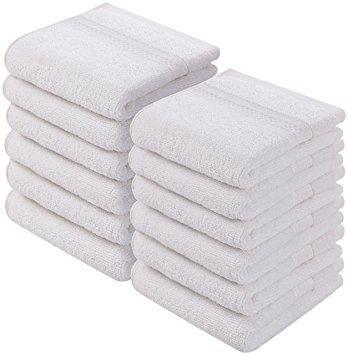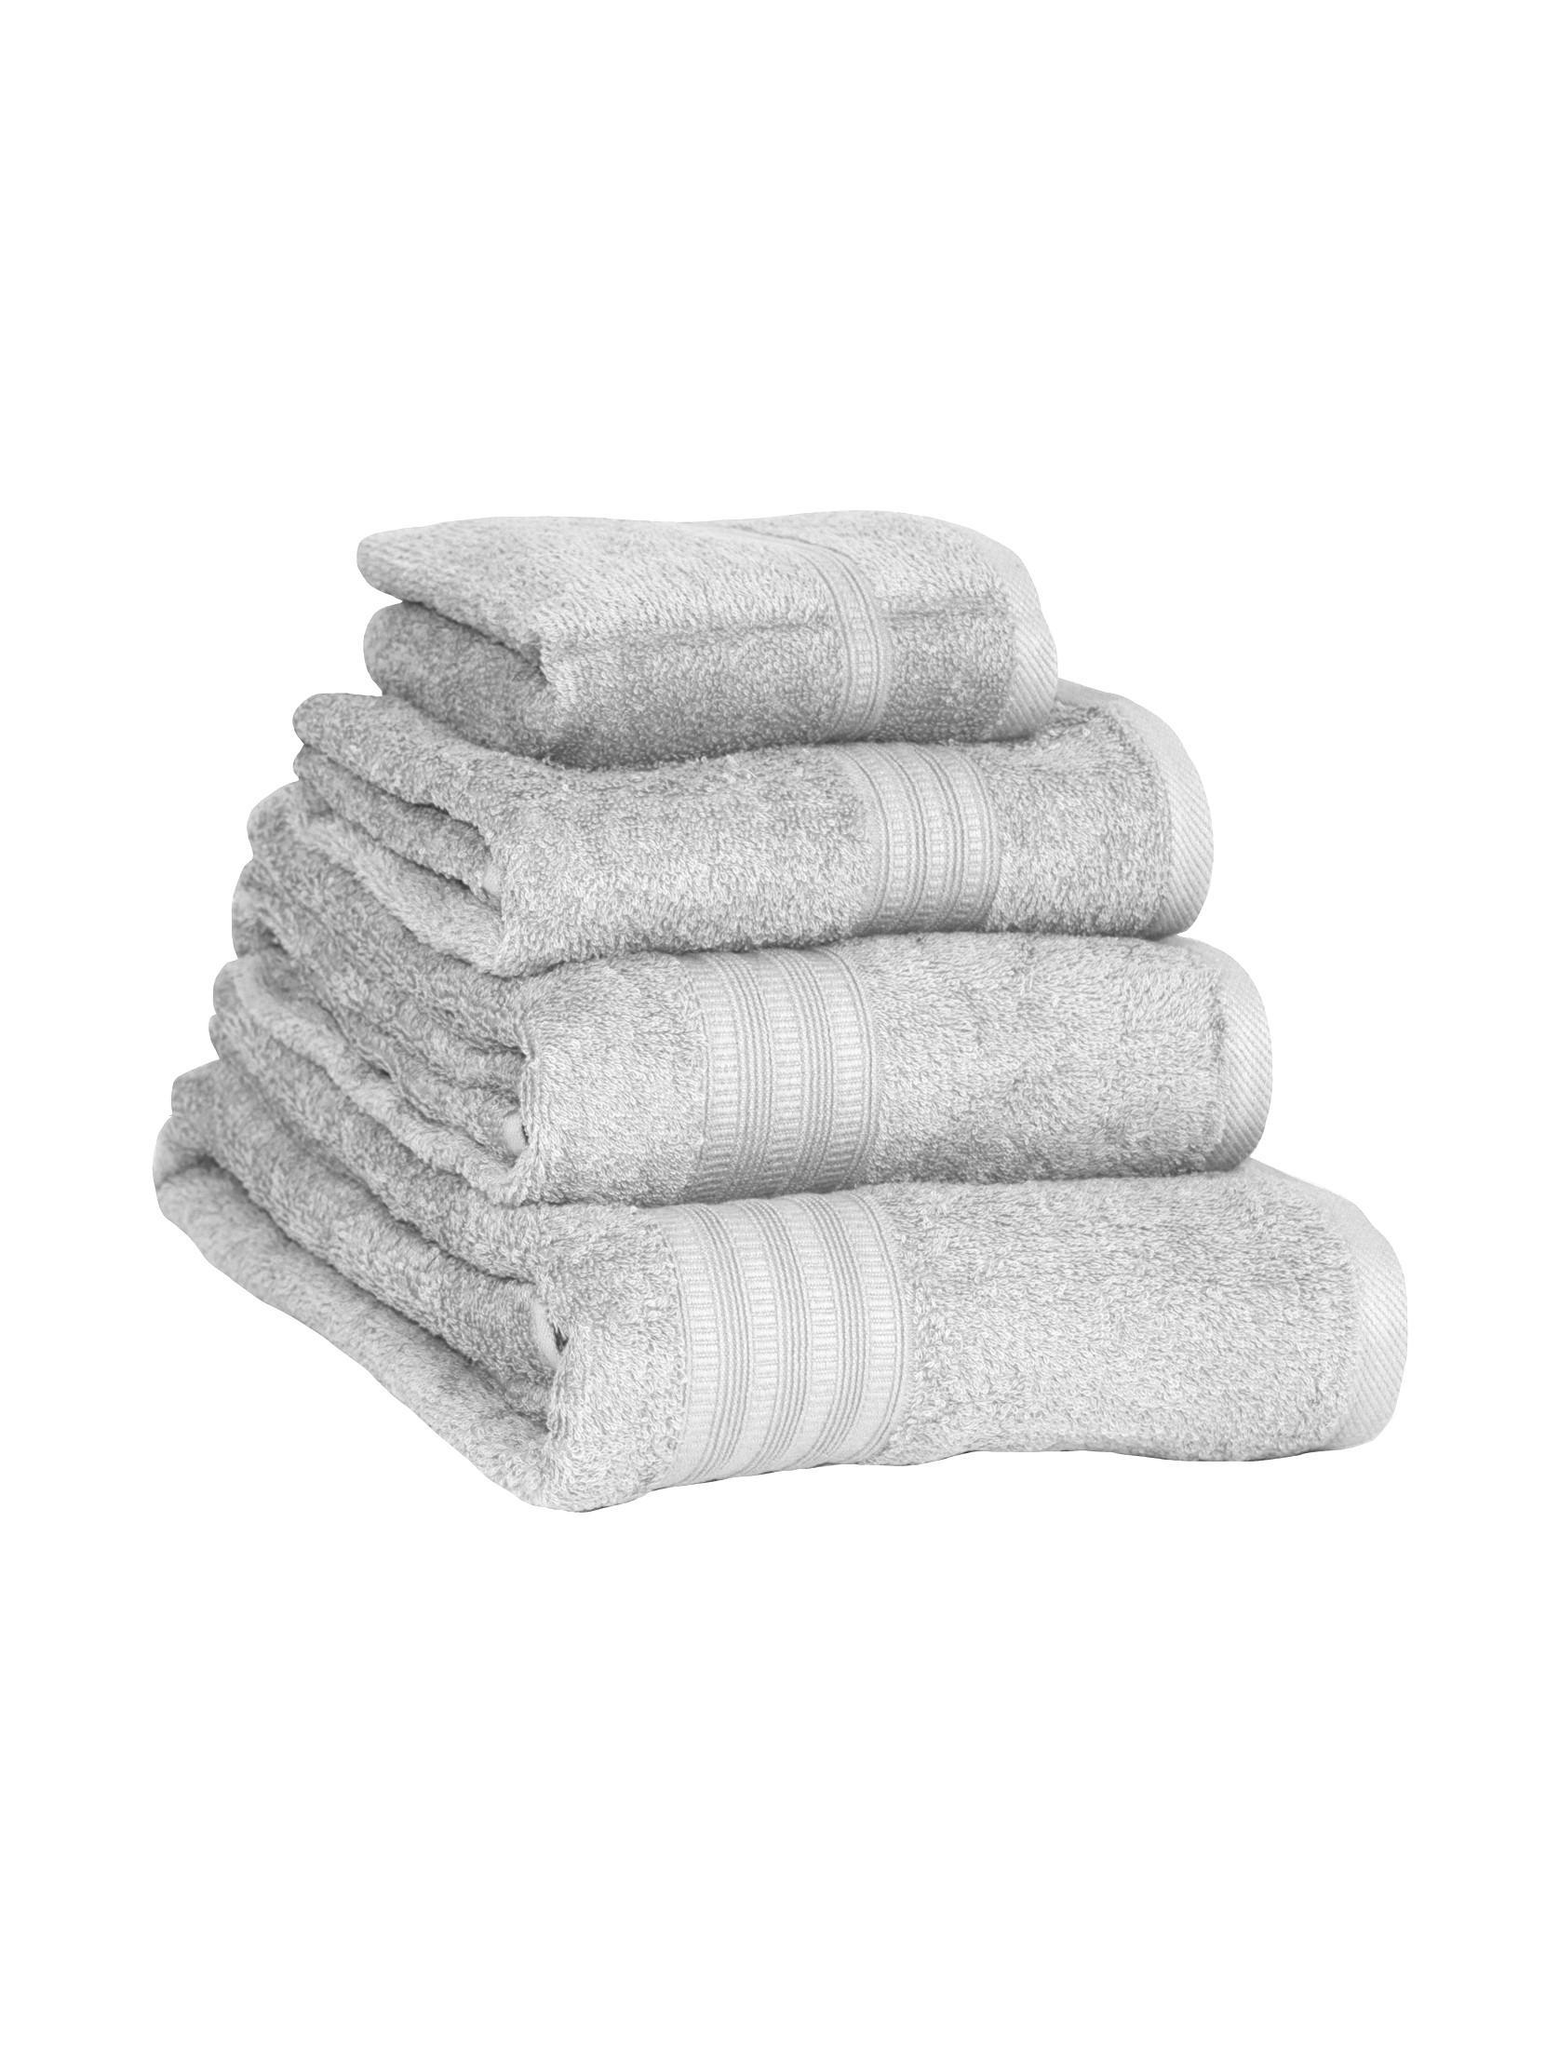The first image is the image on the left, the second image is the image on the right. Analyze the images presented: Is the assertion "At least one of the towels is brown." valid? Answer yes or no. No. The first image is the image on the left, the second image is the image on the right. Given the left and right images, does the statement "There are four towels in the right image." hold true? Answer yes or no. Yes. 